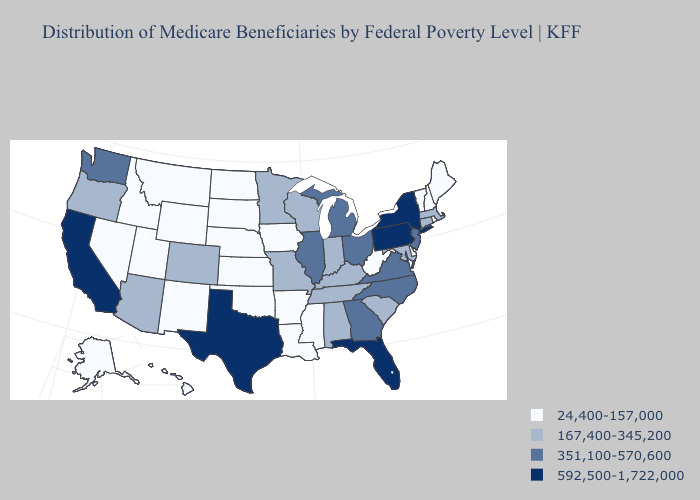Name the states that have a value in the range 24,400-157,000?
Short answer required. Alaska, Arkansas, Delaware, Hawaii, Idaho, Iowa, Kansas, Louisiana, Maine, Mississippi, Montana, Nebraska, Nevada, New Hampshire, New Mexico, North Dakota, Oklahoma, Rhode Island, South Dakota, Utah, Vermont, West Virginia, Wyoming. Does New Jersey have the lowest value in the USA?
Write a very short answer. No. Name the states that have a value in the range 351,100-570,600?
Answer briefly. Georgia, Illinois, Michigan, New Jersey, North Carolina, Ohio, Virginia, Washington. What is the highest value in the MidWest ?
Give a very brief answer. 351,100-570,600. Among the states that border New Hampshire , does Massachusetts have the highest value?
Keep it brief. Yes. What is the lowest value in the South?
Keep it brief. 24,400-157,000. Among the states that border New Hampshire , does Maine have the highest value?
Be succinct. No. Does Louisiana have the highest value in the South?
Give a very brief answer. No. Does the map have missing data?
Keep it brief. No. Name the states that have a value in the range 167,400-345,200?
Keep it brief. Alabama, Arizona, Colorado, Connecticut, Indiana, Kentucky, Maryland, Massachusetts, Minnesota, Missouri, Oregon, South Carolina, Tennessee, Wisconsin. What is the value of Kentucky?
Short answer required. 167,400-345,200. What is the value of Tennessee?
Be succinct. 167,400-345,200. What is the value of Oklahoma?
Be succinct. 24,400-157,000. What is the lowest value in the West?
Answer briefly. 24,400-157,000. What is the value of West Virginia?
Quick response, please. 24,400-157,000. 